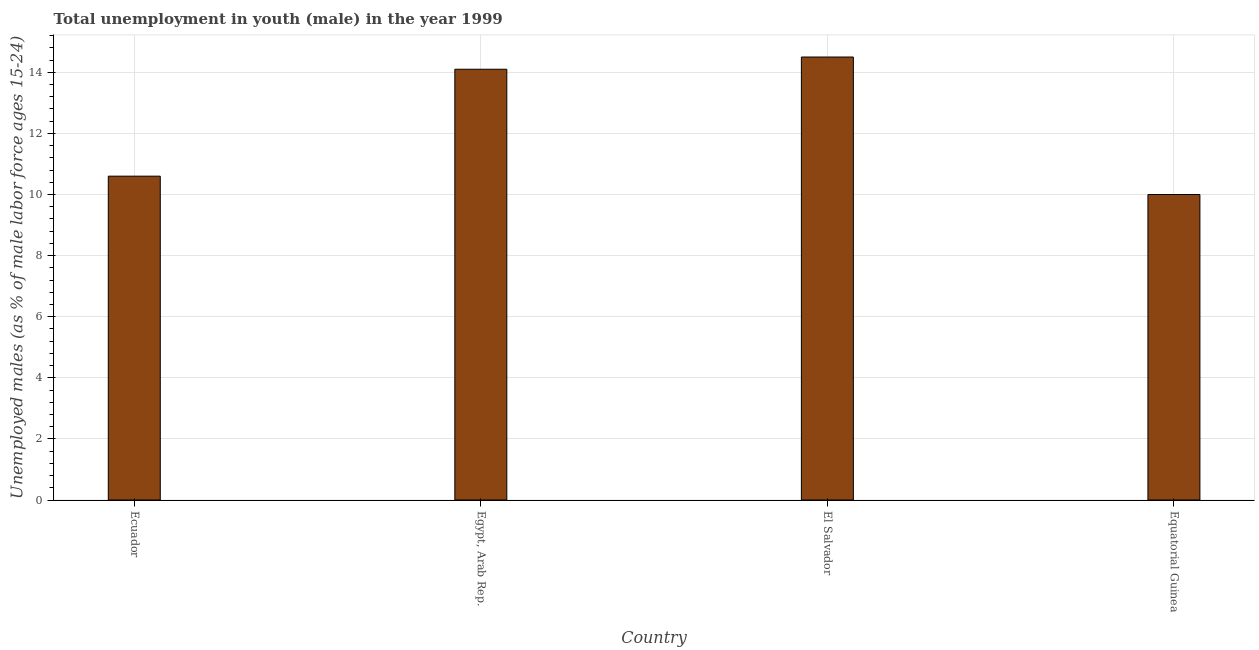Does the graph contain any zero values?
Your response must be concise. No. What is the title of the graph?
Give a very brief answer. Total unemployment in youth (male) in the year 1999. What is the label or title of the X-axis?
Offer a very short reply. Country. What is the label or title of the Y-axis?
Provide a short and direct response. Unemployed males (as % of male labor force ages 15-24). What is the unemployed male youth population in Egypt, Arab Rep.?
Offer a very short reply. 14.1. In which country was the unemployed male youth population maximum?
Make the answer very short. El Salvador. In which country was the unemployed male youth population minimum?
Give a very brief answer. Equatorial Guinea. What is the sum of the unemployed male youth population?
Your answer should be very brief. 49.2. What is the difference between the unemployed male youth population in El Salvador and Equatorial Guinea?
Offer a terse response. 4.5. What is the median unemployed male youth population?
Make the answer very short. 12.35. In how many countries, is the unemployed male youth population greater than 2.4 %?
Your response must be concise. 4. What is the ratio of the unemployed male youth population in Ecuador to that in Equatorial Guinea?
Your answer should be very brief. 1.06. Is the difference between the unemployed male youth population in Egypt, Arab Rep. and El Salvador greater than the difference between any two countries?
Offer a very short reply. No. Is the sum of the unemployed male youth population in Egypt, Arab Rep. and Equatorial Guinea greater than the maximum unemployed male youth population across all countries?
Offer a very short reply. Yes. How many bars are there?
Your response must be concise. 4. Are all the bars in the graph horizontal?
Give a very brief answer. No. How many countries are there in the graph?
Offer a terse response. 4. What is the difference between two consecutive major ticks on the Y-axis?
Keep it short and to the point. 2. Are the values on the major ticks of Y-axis written in scientific E-notation?
Your answer should be compact. No. What is the Unemployed males (as % of male labor force ages 15-24) of Ecuador?
Offer a very short reply. 10.6. What is the Unemployed males (as % of male labor force ages 15-24) in Egypt, Arab Rep.?
Provide a short and direct response. 14.1. What is the Unemployed males (as % of male labor force ages 15-24) in El Salvador?
Your answer should be compact. 14.5. What is the difference between the Unemployed males (as % of male labor force ages 15-24) in Ecuador and El Salvador?
Your answer should be very brief. -3.9. What is the difference between the Unemployed males (as % of male labor force ages 15-24) in Ecuador and Equatorial Guinea?
Provide a succinct answer. 0.6. What is the difference between the Unemployed males (as % of male labor force ages 15-24) in Egypt, Arab Rep. and El Salvador?
Your response must be concise. -0.4. What is the difference between the Unemployed males (as % of male labor force ages 15-24) in Egypt, Arab Rep. and Equatorial Guinea?
Offer a very short reply. 4.1. What is the difference between the Unemployed males (as % of male labor force ages 15-24) in El Salvador and Equatorial Guinea?
Your answer should be very brief. 4.5. What is the ratio of the Unemployed males (as % of male labor force ages 15-24) in Ecuador to that in Egypt, Arab Rep.?
Make the answer very short. 0.75. What is the ratio of the Unemployed males (as % of male labor force ages 15-24) in Ecuador to that in El Salvador?
Your answer should be compact. 0.73. What is the ratio of the Unemployed males (as % of male labor force ages 15-24) in Ecuador to that in Equatorial Guinea?
Provide a short and direct response. 1.06. What is the ratio of the Unemployed males (as % of male labor force ages 15-24) in Egypt, Arab Rep. to that in El Salvador?
Provide a short and direct response. 0.97. What is the ratio of the Unemployed males (as % of male labor force ages 15-24) in Egypt, Arab Rep. to that in Equatorial Guinea?
Make the answer very short. 1.41. What is the ratio of the Unemployed males (as % of male labor force ages 15-24) in El Salvador to that in Equatorial Guinea?
Ensure brevity in your answer.  1.45. 